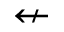Convert formula to latex. <formula><loc_0><loc_0><loc_500><loc_500>\ n l e f t a r r o w</formula> 